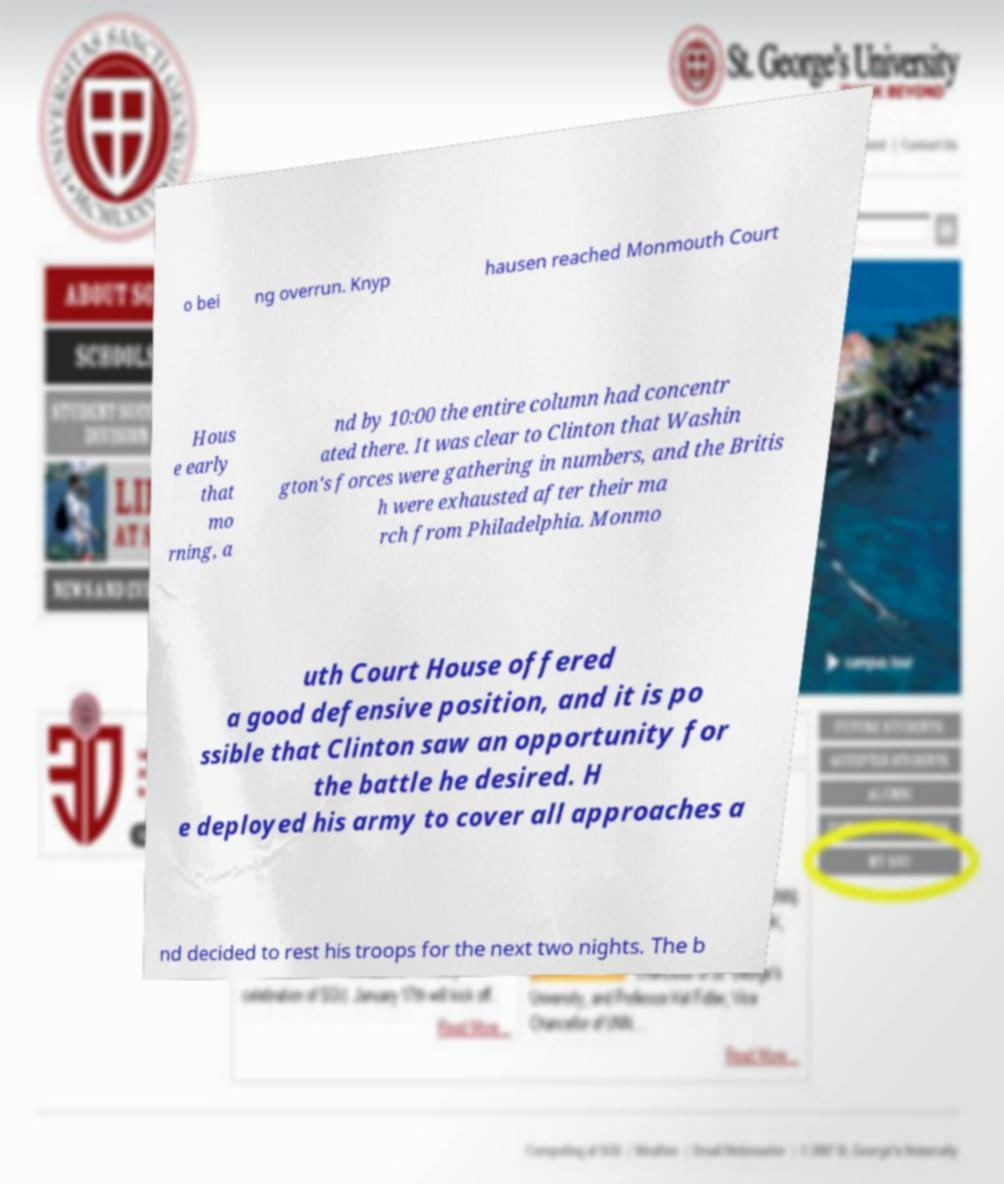Can you read and provide the text displayed in the image?This photo seems to have some interesting text. Can you extract and type it out for me? o bei ng overrun. Knyp hausen reached Monmouth Court Hous e early that mo rning, a nd by 10:00 the entire column had concentr ated there. It was clear to Clinton that Washin gton's forces were gathering in numbers, and the Britis h were exhausted after their ma rch from Philadelphia. Monmo uth Court House offered a good defensive position, and it is po ssible that Clinton saw an opportunity for the battle he desired. H e deployed his army to cover all approaches a nd decided to rest his troops for the next two nights. The b 